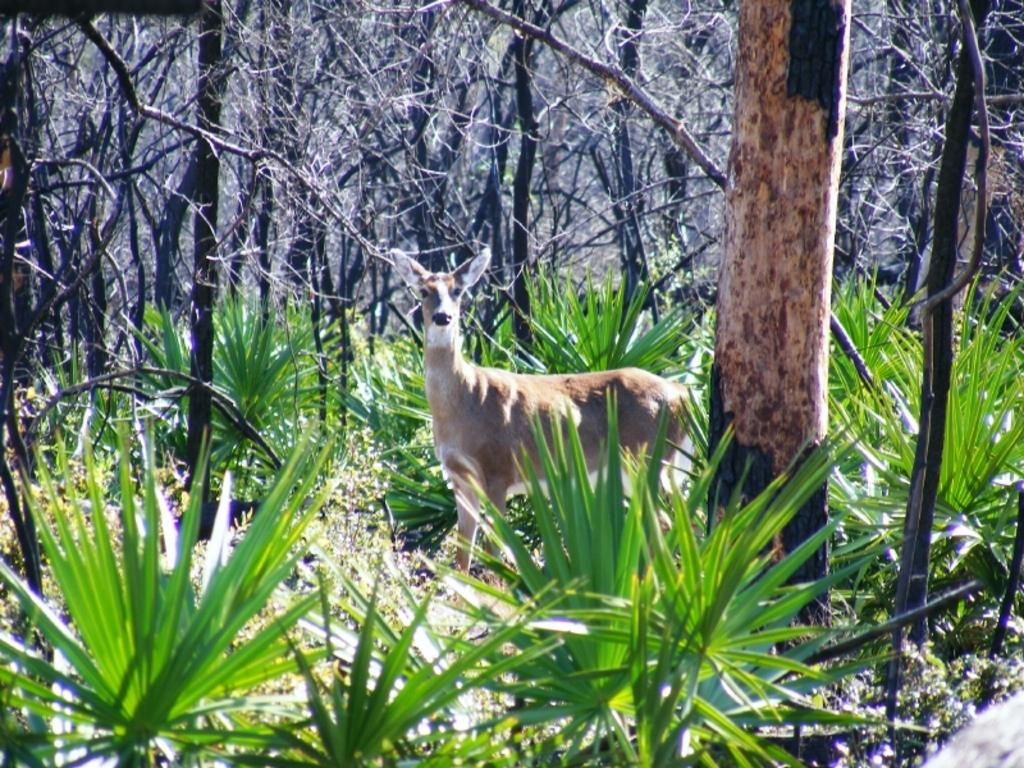What animal can be seen in the image? There is a deer in the image. What can be seen in the background of the image? There are trees in the background of the image. What is covering the ground around the deer? Leaves are visible around the deer. What time is the deer wearing on its wrist in the image? There is no watch present on the deer's wrist in the image. 